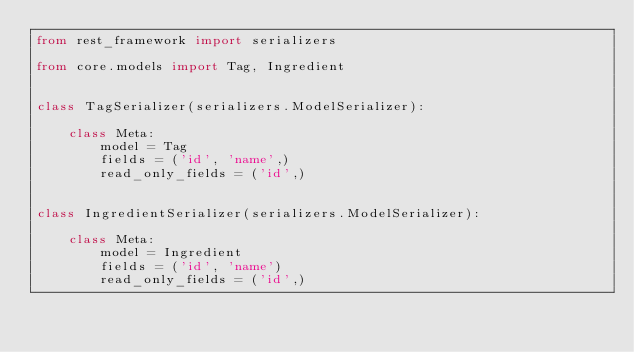Convert code to text. <code><loc_0><loc_0><loc_500><loc_500><_Python_>from rest_framework import serializers

from core.models import Tag, Ingredient


class TagSerializer(serializers.ModelSerializer):

    class Meta:
        model = Tag
        fields = ('id', 'name',)
        read_only_fields = ('id',)


class IngredientSerializer(serializers.ModelSerializer):

    class Meta:
        model = Ingredient
        fields = ('id', 'name')
        read_only_fields = ('id',)
</code> 